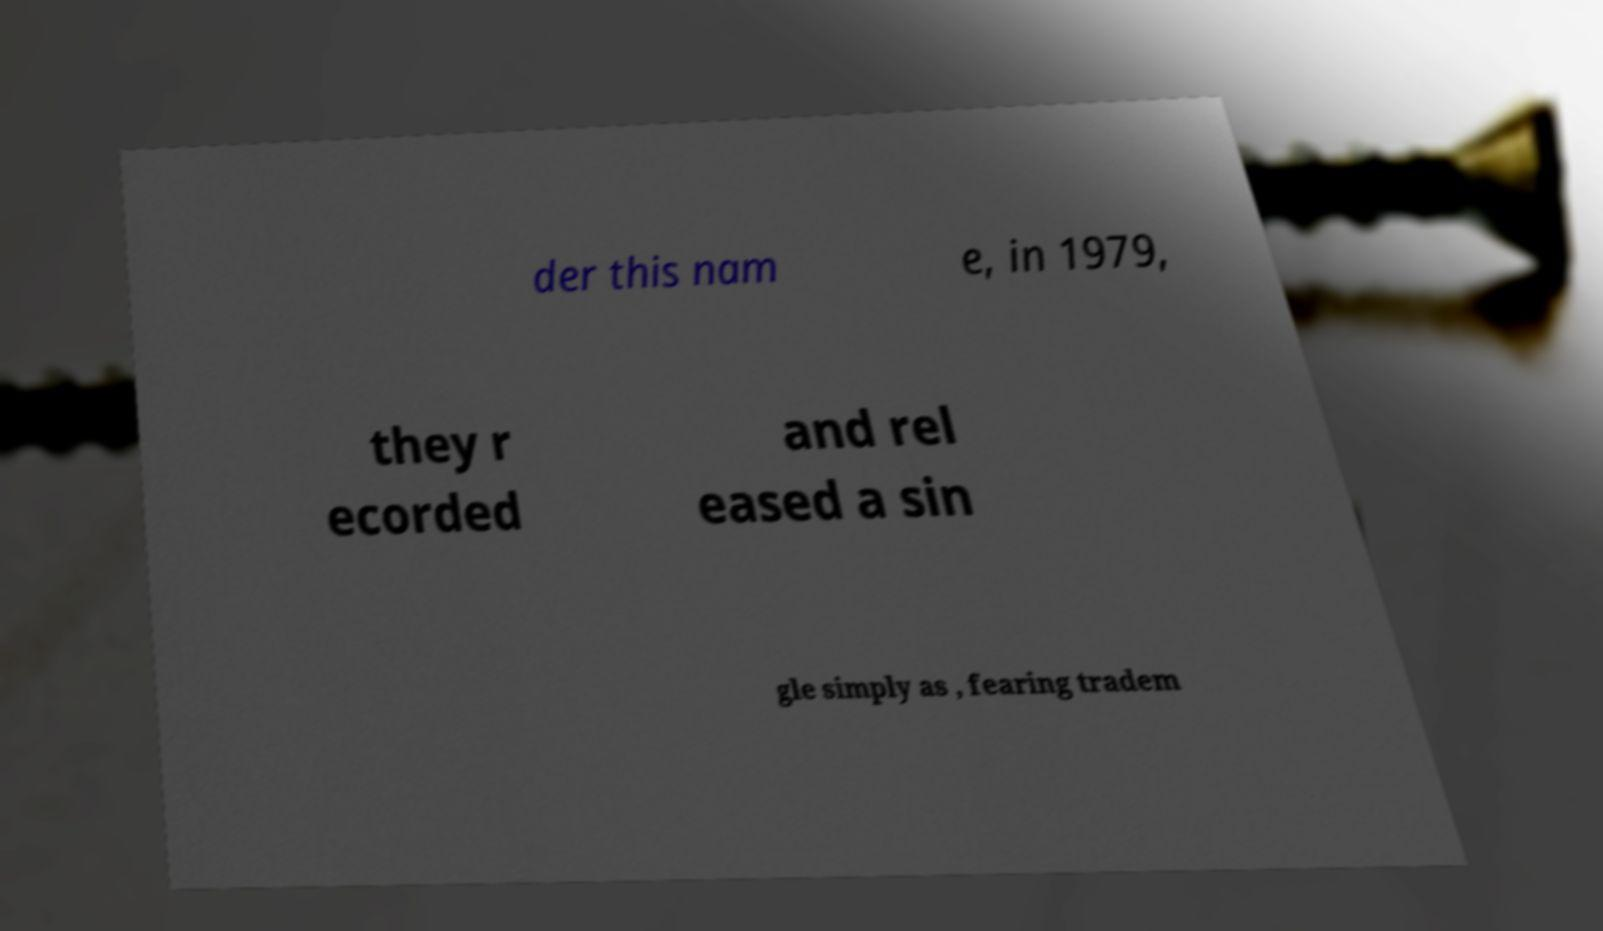Could you assist in decoding the text presented in this image and type it out clearly? der this nam e, in 1979, they r ecorded and rel eased a sin gle simply as , fearing tradem 